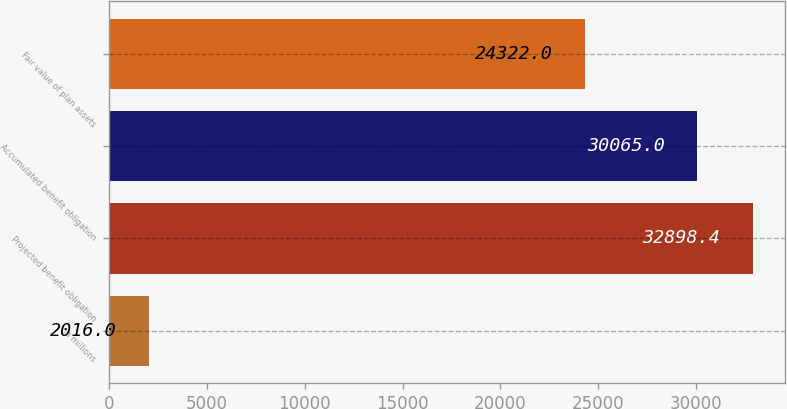Convert chart to OTSL. <chart><loc_0><loc_0><loc_500><loc_500><bar_chart><fcel>in millions<fcel>Projected benefit obligation<fcel>Accumulated benefit obligation<fcel>Fair value of plan assets<nl><fcel>2016<fcel>32898.4<fcel>30065<fcel>24322<nl></chart> 